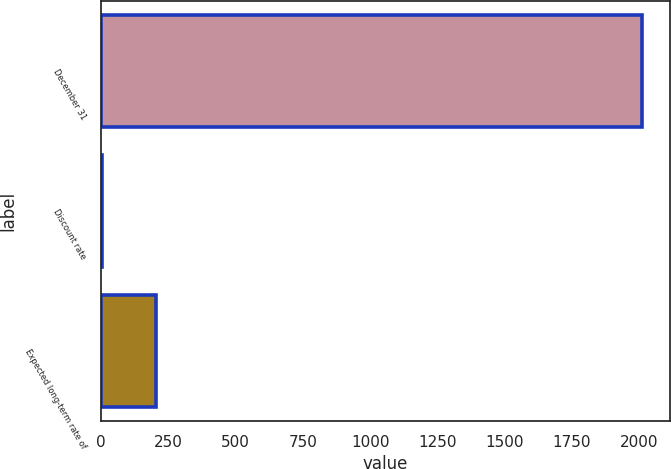Convert chart. <chart><loc_0><loc_0><loc_500><loc_500><bar_chart><fcel>December 31<fcel>Discount rate<fcel>Expected long-term rate of<nl><fcel>2012<fcel>4.75<fcel>205.48<nl></chart> 